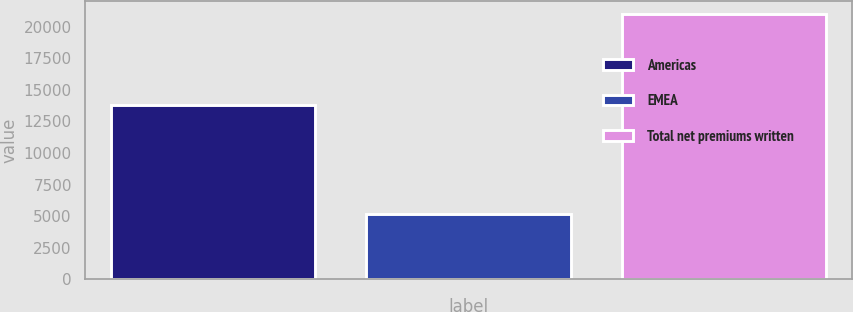Convert chart. <chart><loc_0><loc_0><loc_500><loc_500><bar_chart><fcel>Americas<fcel>EMEA<fcel>Total net premiums written<nl><fcel>13799<fcel>5192<fcel>21020<nl></chart> 